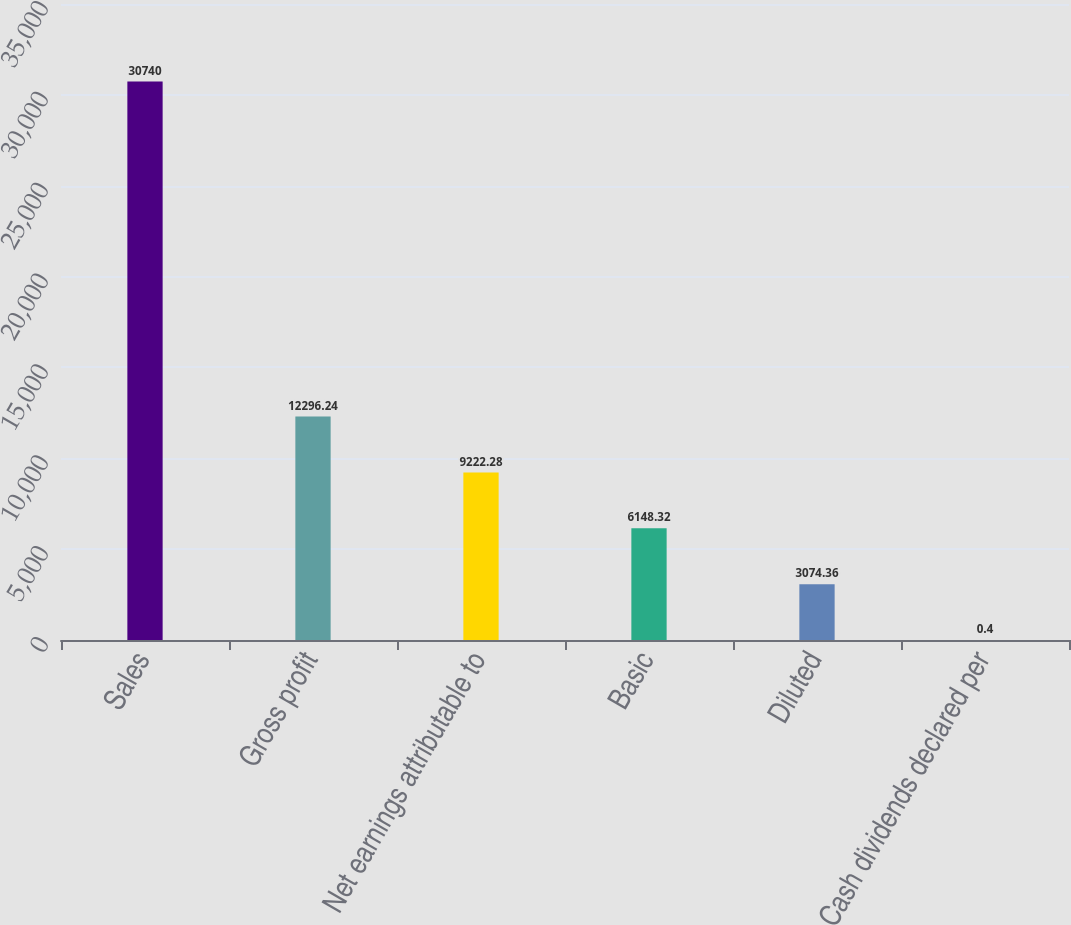Convert chart to OTSL. <chart><loc_0><loc_0><loc_500><loc_500><bar_chart><fcel>Sales<fcel>Gross profit<fcel>Net earnings attributable to<fcel>Basic<fcel>Diluted<fcel>Cash dividends declared per<nl><fcel>30740<fcel>12296.2<fcel>9222.28<fcel>6148.32<fcel>3074.36<fcel>0.4<nl></chart> 